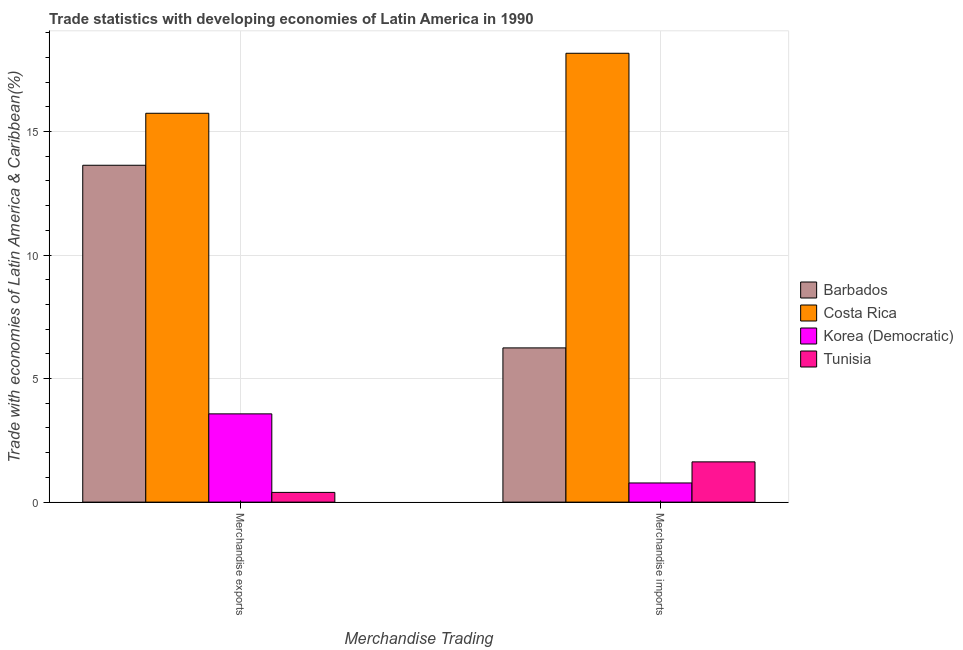What is the label of the 1st group of bars from the left?
Your response must be concise. Merchandise exports. What is the merchandise exports in Barbados?
Your answer should be very brief. 13.63. Across all countries, what is the maximum merchandise exports?
Ensure brevity in your answer.  15.74. Across all countries, what is the minimum merchandise exports?
Provide a short and direct response. 0.39. In which country was the merchandise exports minimum?
Your response must be concise. Tunisia. What is the total merchandise imports in the graph?
Keep it short and to the point. 26.81. What is the difference between the merchandise exports in Barbados and that in Korea (Democratic)?
Your answer should be compact. 10.06. What is the difference between the merchandise exports in Costa Rica and the merchandise imports in Barbados?
Give a very brief answer. 9.49. What is the average merchandise exports per country?
Give a very brief answer. 8.33. What is the difference between the merchandise imports and merchandise exports in Tunisia?
Your answer should be very brief. 1.24. In how many countries, is the merchandise exports greater than 8 %?
Your answer should be compact. 2. What is the ratio of the merchandise exports in Barbados to that in Tunisia?
Keep it short and to the point. 34.61. Is the merchandise exports in Korea (Democratic) less than that in Barbados?
Your answer should be very brief. Yes. In how many countries, is the merchandise exports greater than the average merchandise exports taken over all countries?
Your answer should be very brief. 2. What does the 3rd bar from the left in Merchandise imports represents?
Provide a short and direct response. Korea (Democratic). How many countries are there in the graph?
Provide a short and direct response. 4. What is the difference between two consecutive major ticks on the Y-axis?
Ensure brevity in your answer.  5. Are the values on the major ticks of Y-axis written in scientific E-notation?
Ensure brevity in your answer.  No. Does the graph contain any zero values?
Make the answer very short. No. What is the title of the graph?
Your answer should be compact. Trade statistics with developing economies of Latin America in 1990. What is the label or title of the X-axis?
Offer a terse response. Merchandise Trading. What is the label or title of the Y-axis?
Make the answer very short. Trade with economies of Latin America & Caribbean(%). What is the Trade with economies of Latin America & Caribbean(%) in Barbados in Merchandise exports?
Make the answer very short. 13.63. What is the Trade with economies of Latin America & Caribbean(%) in Costa Rica in Merchandise exports?
Offer a very short reply. 15.74. What is the Trade with economies of Latin America & Caribbean(%) in Korea (Democratic) in Merchandise exports?
Provide a short and direct response. 3.57. What is the Trade with economies of Latin America & Caribbean(%) of Tunisia in Merchandise exports?
Offer a very short reply. 0.39. What is the Trade with economies of Latin America & Caribbean(%) of Barbados in Merchandise imports?
Provide a succinct answer. 6.24. What is the Trade with economies of Latin America & Caribbean(%) of Costa Rica in Merchandise imports?
Your answer should be very brief. 18.16. What is the Trade with economies of Latin America & Caribbean(%) of Korea (Democratic) in Merchandise imports?
Give a very brief answer. 0.78. What is the Trade with economies of Latin America & Caribbean(%) in Tunisia in Merchandise imports?
Give a very brief answer. 1.63. Across all Merchandise Trading, what is the maximum Trade with economies of Latin America & Caribbean(%) of Barbados?
Provide a short and direct response. 13.63. Across all Merchandise Trading, what is the maximum Trade with economies of Latin America & Caribbean(%) of Costa Rica?
Your answer should be very brief. 18.16. Across all Merchandise Trading, what is the maximum Trade with economies of Latin America & Caribbean(%) in Korea (Democratic)?
Make the answer very short. 3.57. Across all Merchandise Trading, what is the maximum Trade with economies of Latin America & Caribbean(%) of Tunisia?
Keep it short and to the point. 1.63. Across all Merchandise Trading, what is the minimum Trade with economies of Latin America & Caribbean(%) in Barbados?
Keep it short and to the point. 6.24. Across all Merchandise Trading, what is the minimum Trade with economies of Latin America & Caribbean(%) in Costa Rica?
Your answer should be very brief. 15.74. Across all Merchandise Trading, what is the minimum Trade with economies of Latin America & Caribbean(%) in Korea (Democratic)?
Offer a very short reply. 0.78. Across all Merchandise Trading, what is the minimum Trade with economies of Latin America & Caribbean(%) of Tunisia?
Ensure brevity in your answer.  0.39. What is the total Trade with economies of Latin America & Caribbean(%) in Barbados in the graph?
Offer a very short reply. 19.87. What is the total Trade with economies of Latin America & Caribbean(%) in Costa Rica in the graph?
Make the answer very short. 33.9. What is the total Trade with economies of Latin America & Caribbean(%) of Korea (Democratic) in the graph?
Offer a very short reply. 4.35. What is the total Trade with economies of Latin America & Caribbean(%) of Tunisia in the graph?
Your answer should be very brief. 2.02. What is the difference between the Trade with economies of Latin America & Caribbean(%) of Barbados in Merchandise exports and that in Merchandise imports?
Make the answer very short. 7.39. What is the difference between the Trade with economies of Latin America & Caribbean(%) of Costa Rica in Merchandise exports and that in Merchandise imports?
Ensure brevity in your answer.  -2.43. What is the difference between the Trade with economies of Latin America & Caribbean(%) in Korea (Democratic) in Merchandise exports and that in Merchandise imports?
Offer a terse response. 2.8. What is the difference between the Trade with economies of Latin America & Caribbean(%) in Tunisia in Merchandise exports and that in Merchandise imports?
Your answer should be compact. -1.24. What is the difference between the Trade with economies of Latin America & Caribbean(%) in Barbados in Merchandise exports and the Trade with economies of Latin America & Caribbean(%) in Costa Rica in Merchandise imports?
Provide a short and direct response. -4.53. What is the difference between the Trade with economies of Latin America & Caribbean(%) of Barbados in Merchandise exports and the Trade with economies of Latin America & Caribbean(%) of Korea (Democratic) in Merchandise imports?
Ensure brevity in your answer.  12.86. What is the difference between the Trade with economies of Latin America & Caribbean(%) in Barbados in Merchandise exports and the Trade with economies of Latin America & Caribbean(%) in Tunisia in Merchandise imports?
Your response must be concise. 12. What is the difference between the Trade with economies of Latin America & Caribbean(%) of Costa Rica in Merchandise exports and the Trade with economies of Latin America & Caribbean(%) of Korea (Democratic) in Merchandise imports?
Provide a succinct answer. 14.96. What is the difference between the Trade with economies of Latin America & Caribbean(%) in Costa Rica in Merchandise exports and the Trade with economies of Latin America & Caribbean(%) in Tunisia in Merchandise imports?
Your answer should be very brief. 14.11. What is the difference between the Trade with economies of Latin America & Caribbean(%) of Korea (Democratic) in Merchandise exports and the Trade with economies of Latin America & Caribbean(%) of Tunisia in Merchandise imports?
Provide a succinct answer. 1.94. What is the average Trade with economies of Latin America & Caribbean(%) in Barbados per Merchandise Trading?
Offer a terse response. 9.94. What is the average Trade with economies of Latin America & Caribbean(%) of Costa Rica per Merchandise Trading?
Ensure brevity in your answer.  16.95. What is the average Trade with economies of Latin America & Caribbean(%) in Korea (Democratic) per Merchandise Trading?
Ensure brevity in your answer.  2.17. What is the average Trade with economies of Latin America & Caribbean(%) in Tunisia per Merchandise Trading?
Provide a succinct answer. 1.01. What is the difference between the Trade with economies of Latin America & Caribbean(%) in Barbados and Trade with economies of Latin America & Caribbean(%) in Costa Rica in Merchandise exports?
Your response must be concise. -2.1. What is the difference between the Trade with economies of Latin America & Caribbean(%) in Barbados and Trade with economies of Latin America & Caribbean(%) in Korea (Democratic) in Merchandise exports?
Offer a terse response. 10.06. What is the difference between the Trade with economies of Latin America & Caribbean(%) in Barbados and Trade with economies of Latin America & Caribbean(%) in Tunisia in Merchandise exports?
Ensure brevity in your answer.  13.24. What is the difference between the Trade with economies of Latin America & Caribbean(%) in Costa Rica and Trade with economies of Latin America & Caribbean(%) in Korea (Democratic) in Merchandise exports?
Provide a succinct answer. 12.16. What is the difference between the Trade with economies of Latin America & Caribbean(%) in Costa Rica and Trade with economies of Latin America & Caribbean(%) in Tunisia in Merchandise exports?
Provide a succinct answer. 15.34. What is the difference between the Trade with economies of Latin America & Caribbean(%) of Korea (Democratic) and Trade with economies of Latin America & Caribbean(%) of Tunisia in Merchandise exports?
Make the answer very short. 3.18. What is the difference between the Trade with economies of Latin America & Caribbean(%) in Barbados and Trade with economies of Latin America & Caribbean(%) in Costa Rica in Merchandise imports?
Make the answer very short. -11.92. What is the difference between the Trade with economies of Latin America & Caribbean(%) in Barbados and Trade with economies of Latin America & Caribbean(%) in Korea (Democratic) in Merchandise imports?
Offer a very short reply. 5.47. What is the difference between the Trade with economies of Latin America & Caribbean(%) of Barbados and Trade with economies of Latin America & Caribbean(%) of Tunisia in Merchandise imports?
Your answer should be compact. 4.61. What is the difference between the Trade with economies of Latin America & Caribbean(%) of Costa Rica and Trade with economies of Latin America & Caribbean(%) of Korea (Democratic) in Merchandise imports?
Offer a very short reply. 17.39. What is the difference between the Trade with economies of Latin America & Caribbean(%) of Costa Rica and Trade with economies of Latin America & Caribbean(%) of Tunisia in Merchandise imports?
Your answer should be compact. 16.53. What is the difference between the Trade with economies of Latin America & Caribbean(%) of Korea (Democratic) and Trade with economies of Latin America & Caribbean(%) of Tunisia in Merchandise imports?
Offer a terse response. -0.85. What is the ratio of the Trade with economies of Latin America & Caribbean(%) in Barbados in Merchandise exports to that in Merchandise imports?
Ensure brevity in your answer.  2.18. What is the ratio of the Trade with economies of Latin America & Caribbean(%) of Costa Rica in Merchandise exports to that in Merchandise imports?
Keep it short and to the point. 0.87. What is the ratio of the Trade with economies of Latin America & Caribbean(%) in Korea (Democratic) in Merchandise exports to that in Merchandise imports?
Your answer should be very brief. 4.61. What is the ratio of the Trade with economies of Latin America & Caribbean(%) in Tunisia in Merchandise exports to that in Merchandise imports?
Provide a succinct answer. 0.24. What is the difference between the highest and the second highest Trade with economies of Latin America & Caribbean(%) in Barbados?
Keep it short and to the point. 7.39. What is the difference between the highest and the second highest Trade with economies of Latin America & Caribbean(%) in Costa Rica?
Provide a short and direct response. 2.43. What is the difference between the highest and the second highest Trade with economies of Latin America & Caribbean(%) in Korea (Democratic)?
Your answer should be compact. 2.8. What is the difference between the highest and the second highest Trade with economies of Latin America & Caribbean(%) in Tunisia?
Your response must be concise. 1.24. What is the difference between the highest and the lowest Trade with economies of Latin America & Caribbean(%) of Barbados?
Your response must be concise. 7.39. What is the difference between the highest and the lowest Trade with economies of Latin America & Caribbean(%) of Costa Rica?
Provide a short and direct response. 2.43. What is the difference between the highest and the lowest Trade with economies of Latin America & Caribbean(%) in Korea (Democratic)?
Offer a very short reply. 2.8. What is the difference between the highest and the lowest Trade with economies of Latin America & Caribbean(%) in Tunisia?
Offer a terse response. 1.24. 